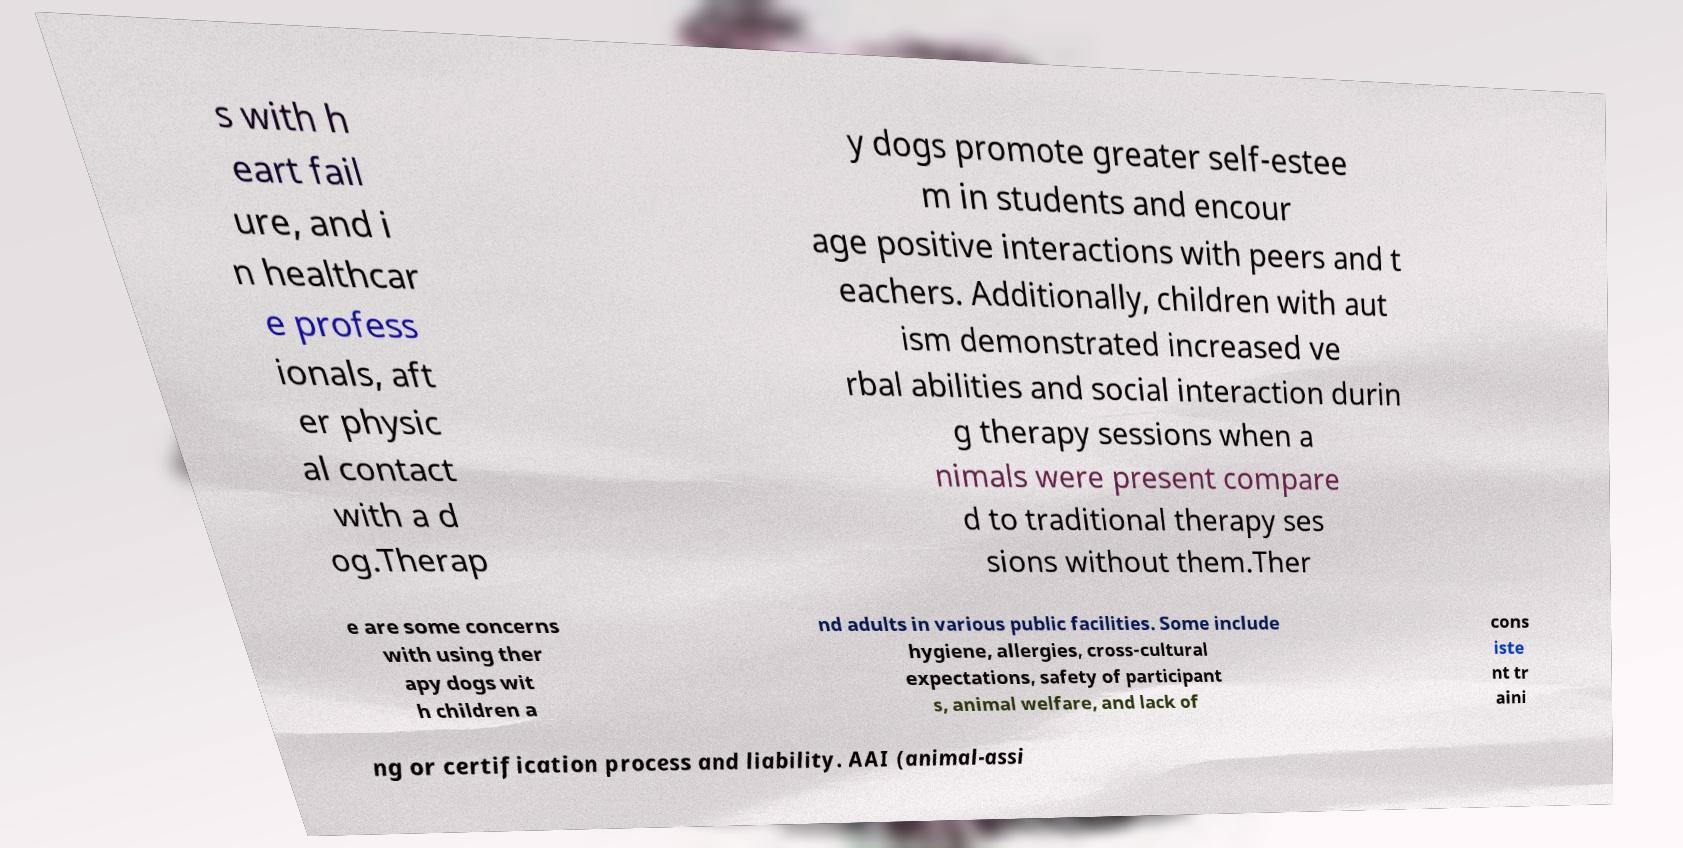What messages or text are displayed in this image? I need them in a readable, typed format. s with h eart fail ure, and i n healthcar e profess ionals, aft er physic al contact with a d og.Therap y dogs promote greater self-estee m in students and encour age positive interactions with peers and t eachers. Additionally, children with aut ism demonstrated increased ve rbal abilities and social interaction durin g therapy sessions when a nimals were present compare d to traditional therapy ses sions without them.Ther e are some concerns with using ther apy dogs wit h children a nd adults in various public facilities. Some include hygiene, allergies, cross-cultural expectations, safety of participant s, animal welfare, and lack of cons iste nt tr aini ng or certification process and liability. AAI (animal-assi 